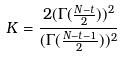Convert formula to latex. <formula><loc_0><loc_0><loc_500><loc_500>K = \frac { 2 ( \Gamma ( \frac { N - t } { 2 } ) ) ^ { 2 } } { ( \Gamma ( \frac { N - t - 1 } { 2 } ) ) ^ { 2 } }</formula> 